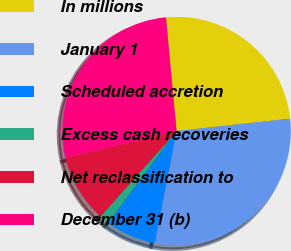Convert chart. <chart><loc_0><loc_0><loc_500><loc_500><pie_chart><fcel>In millions<fcel>January 1<fcel>Scheduled accretion<fcel>Excess cash recoveries<fcel>Net reclassification to<fcel>December 31 (b)<nl><fcel>24.75%<fcel>29.79%<fcel>7.13%<fcel>1.41%<fcel>9.65%<fcel>27.27%<nl></chart> 